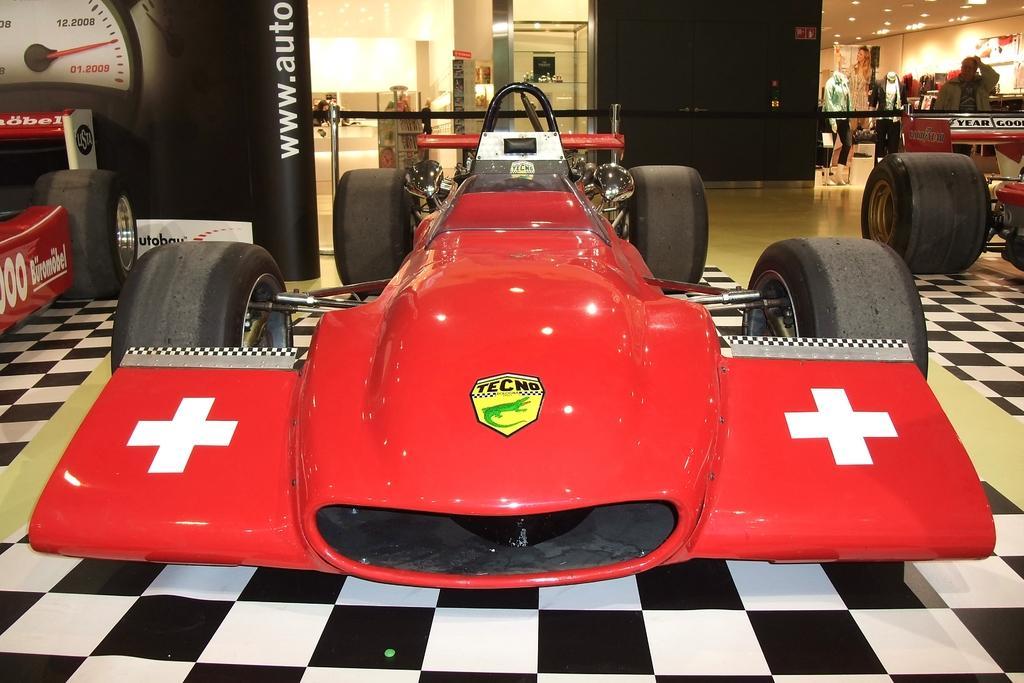Please provide a concise description of this image. In this image there are sports cars parked on the floor. In the top right there are mannequins. Behind the mannequins there are boards. In the top left there is a board on the floor. There are pictures of speedometer and text on the board. There are lights to the ceiling. 